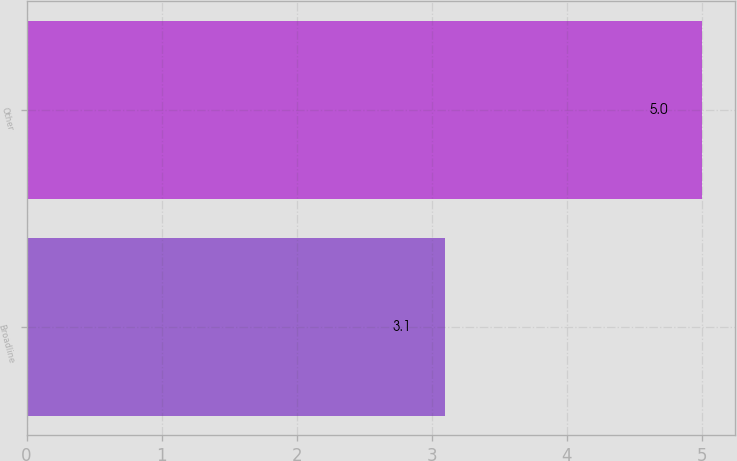<chart> <loc_0><loc_0><loc_500><loc_500><bar_chart><fcel>Broadline<fcel>Other<nl><fcel>3.1<fcel>5<nl></chart> 